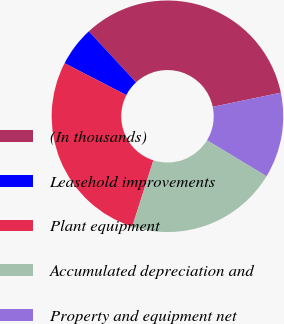Convert chart to OTSL. <chart><loc_0><loc_0><loc_500><loc_500><pie_chart><fcel>(In thousands)<fcel>Leasehold improvements<fcel>Plant equipment<fcel>Accumulated depreciation and<fcel>Property and equipment net<nl><fcel>33.62%<fcel>5.54%<fcel>27.65%<fcel>21.28%<fcel>11.91%<nl></chart> 